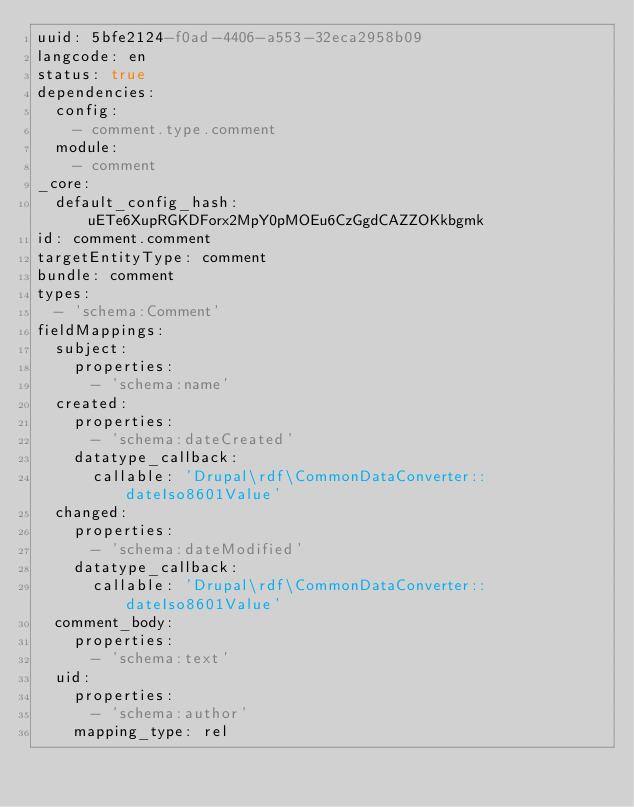Convert code to text. <code><loc_0><loc_0><loc_500><loc_500><_YAML_>uuid: 5bfe2124-f0ad-4406-a553-32eca2958b09
langcode: en
status: true
dependencies:
  config:
    - comment.type.comment
  module:
    - comment
_core:
  default_config_hash: uETe6XupRGKDForx2MpY0pMOEu6CzGgdCAZZOKkbgmk
id: comment.comment
targetEntityType: comment
bundle: comment
types:
  - 'schema:Comment'
fieldMappings:
  subject:
    properties:
      - 'schema:name'
  created:
    properties:
      - 'schema:dateCreated'
    datatype_callback:
      callable: 'Drupal\rdf\CommonDataConverter::dateIso8601Value'
  changed:
    properties:
      - 'schema:dateModified'
    datatype_callback:
      callable: 'Drupal\rdf\CommonDataConverter::dateIso8601Value'
  comment_body:
    properties:
      - 'schema:text'
  uid:
    properties:
      - 'schema:author'
    mapping_type: rel
</code> 